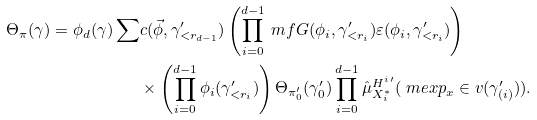Convert formula to latex. <formula><loc_0><loc_0><loc_500><loc_500>\Theta _ { \pi } ( \gamma ) = \phi _ { d } ( \gamma ) \sum & c ( \vec { \phi } , \gamma ^ { \prime } _ { < r _ { d - 1 } } ) \left ( \prod _ { i = 0 } ^ { d - 1 } \ m f G ( \phi _ { i } , \gamma _ { < r _ { i } } ^ { \prime } ) \varepsilon ( \phi _ { i } , \gamma _ { < r _ { i } } ^ { \prime } ) \right ) \\ & \times \left ( \prod _ { i = 0 } ^ { d - 1 } \phi _ { i } ( \gamma ^ { \prime } _ { < r _ { i } } ) \right ) \Theta _ { \pi ^ { \prime } _ { 0 } } ( \gamma ^ { \prime } _ { 0 } ) \prod _ { i = 0 } ^ { d - 1 } \hat { \mu } ^ { H ^ { i \, \prime } } _ { X _ { i } ^ { * } } ( \ m e x p _ { x } \in v ( \gamma ^ { \prime } _ { ( i ) } ) ) .</formula> 